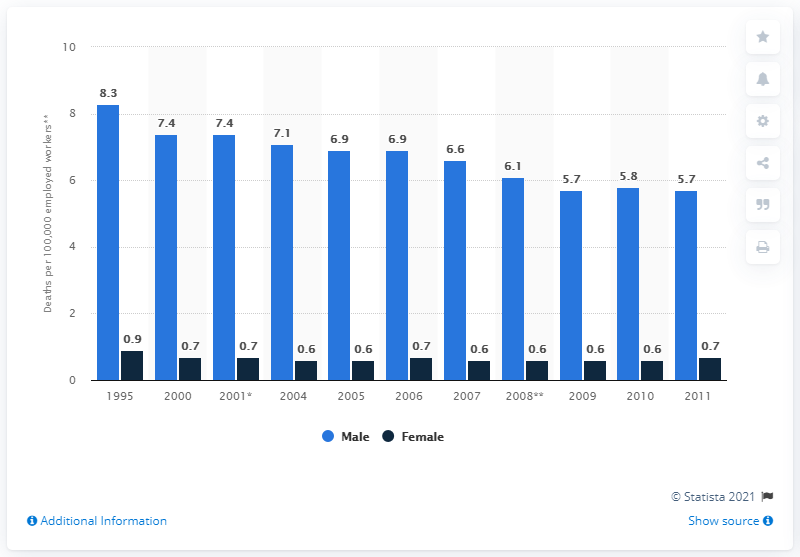List a handful of essential elements in this visual. In 1995, there were approximately 8.3 male occupational injury deaths per 100,000 employed workers in the United States. 